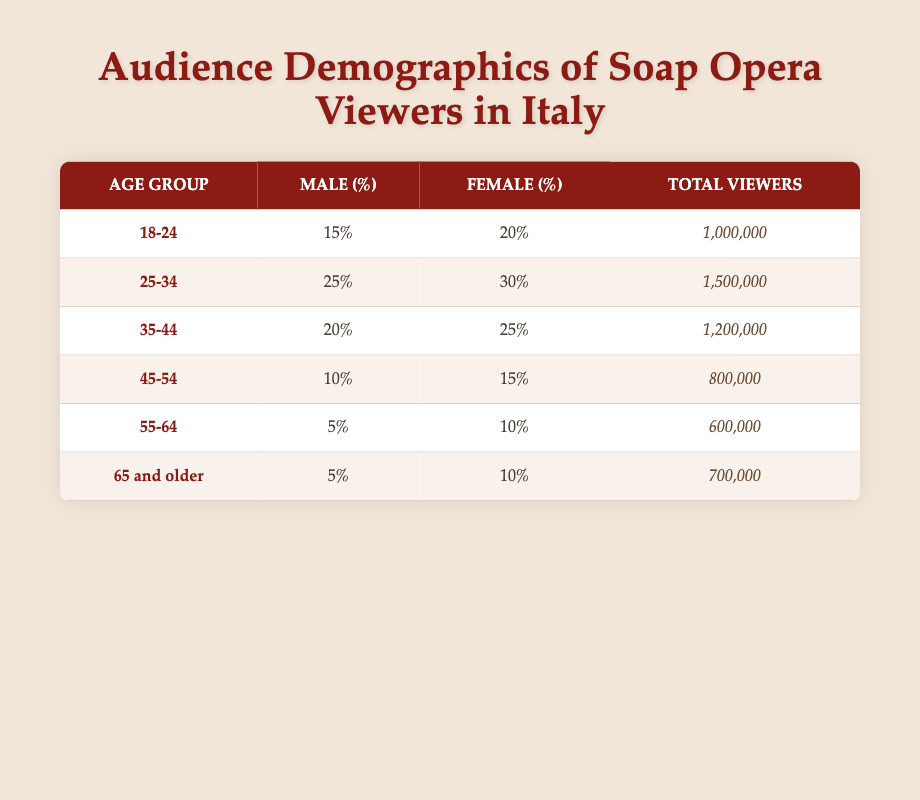What is the total number of viewers in the age group 25-34? From the table, we can see that the total viewers for the age group 25-34 is clearly listed as 1,500,000.
Answer: 1,500,000 What percentage of viewers aged 18-24 are male? According to the table, the percentage of male viewers in the age group 18-24 is stated as 15%.
Answer: 15% Which age group has the highest total number of viewers? Reviewing the total viewers for each age group, we see that the age group 25-34 has the highest total at 1,500,000.
Answer: 25-34 What is the combined percentage of female viewers aged 45-54 and 55-64? To find this, we add the female percentages of the two age groups: 15% (for 45-54) + 10% (for 55-64) = 25%.
Answer: 25% Is it true that the percentage of male viewers is higher in the age group 25-34 compared to the age group 35-44? Yes, the table shows that the male percentage for 25-34 is 25%, while for 35-44 it is 20%.
Answer: Yes What is the average total number of viewers for all age groups combined? We sum the total viewers from each age group: 1,000,000 + 1,500,000 + 1,200,000 + 800,000 + 600,000 + 700,000 = 5,800,000. Then, we divide by the number of age groups (6), resulting in an average of 966,666.67.
Answer: 966,666.67 How many more female viewers are there in the age group 18-24 compared to the age group 55-64? The age group 18-24 has 20% female viewers of 1,000,000, which is 200,000. The age group 55-64 has 10% female viewers of 600,000, which is 60,000. Therefore, 200,000 - 60,000 = 140,000 more female viewers in 18-24.
Answer: 140,000 Which age group has the lowest percentage of male viewers? Reviewing the percentages, we find that the age group 55-64 has the lowest male percentage at 5%.
Answer: 55-64 